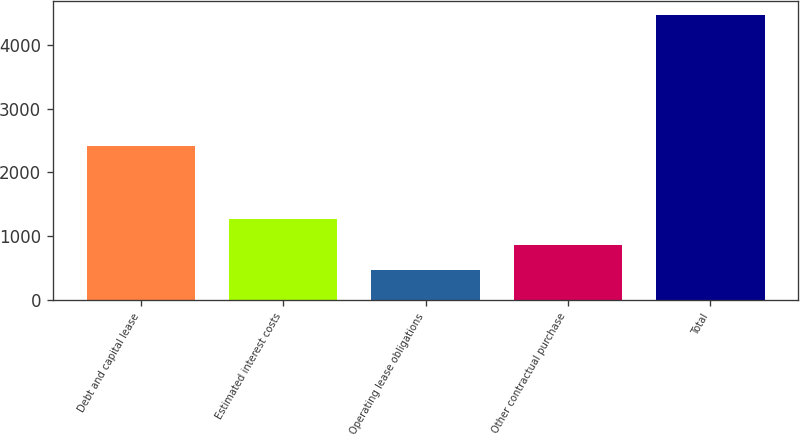<chart> <loc_0><loc_0><loc_500><loc_500><bar_chart><fcel>Debt and capital lease<fcel>Estimated interest costs<fcel>Operating lease obligations<fcel>Other contractual purchase<fcel>Total<nl><fcel>2412<fcel>1266.6<fcel>467<fcel>866.8<fcel>4465<nl></chart> 